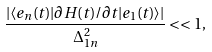Convert formula to latex. <formula><loc_0><loc_0><loc_500><loc_500>\frac { | \langle e _ { n } ( t ) | \partial H ( t ) / \partial t | e _ { 1 } ( t ) \rangle | } { \Delta _ { 1 n } ^ { 2 } } < < 1 ,</formula> 